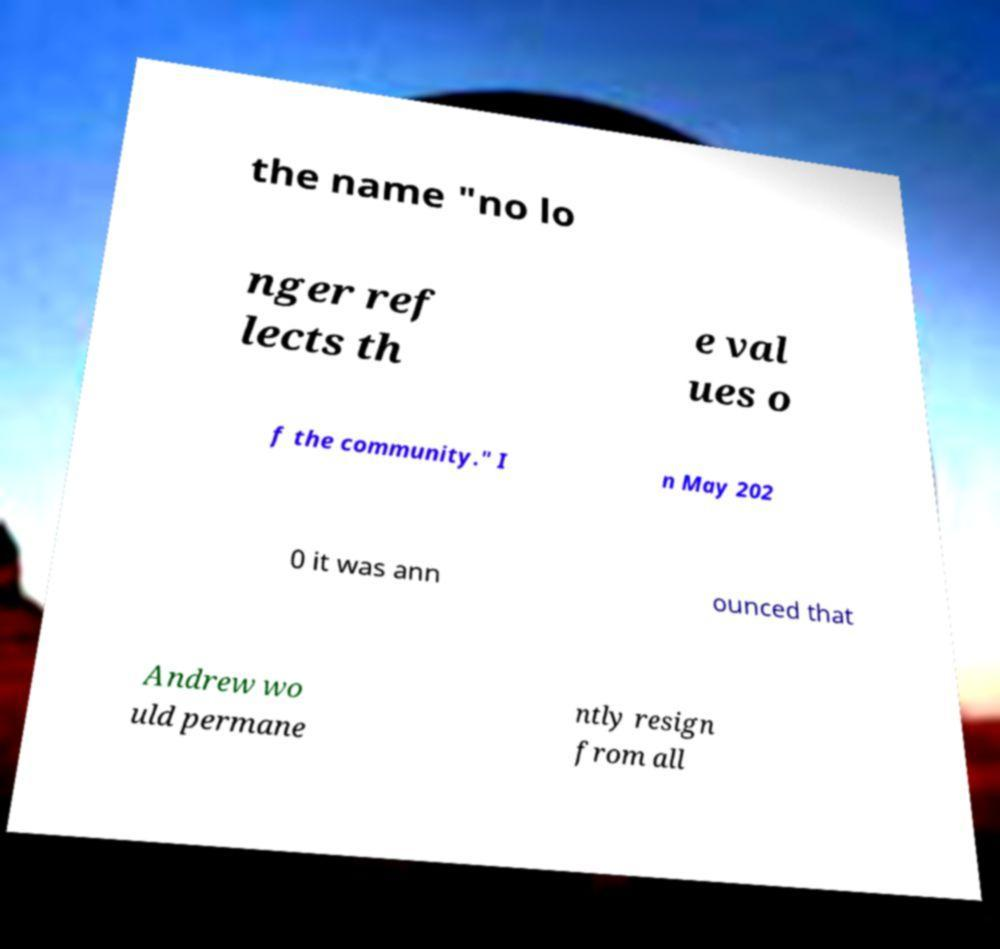Can you accurately transcribe the text from the provided image for me? the name "no lo nger ref lects th e val ues o f the community." I n May 202 0 it was ann ounced that Andrew wo uld permane ntly resign from all 